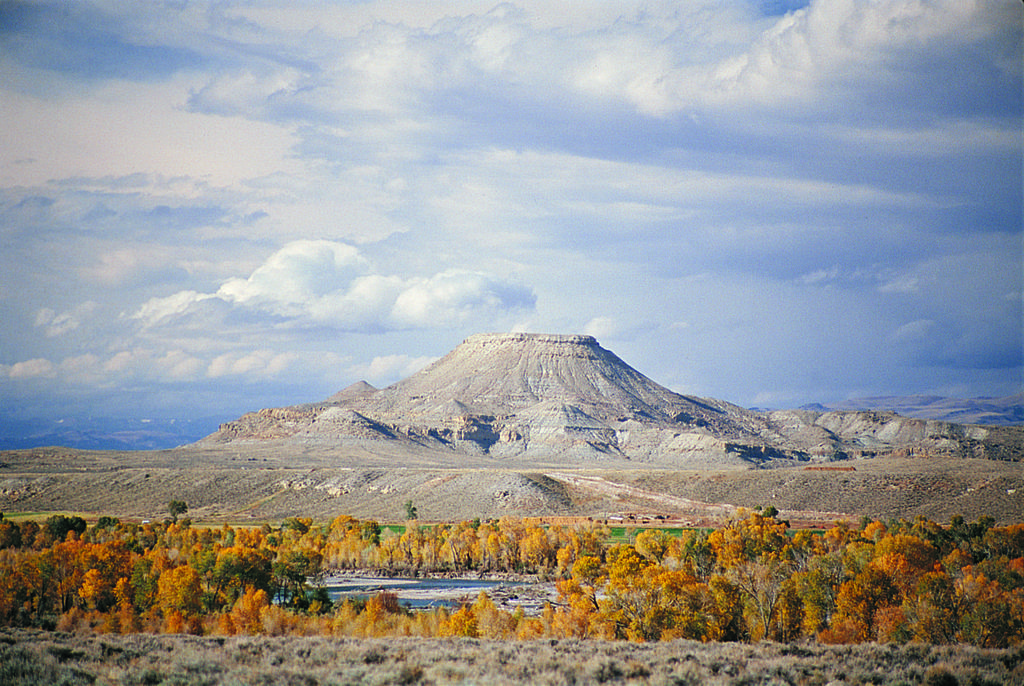Describe this image in one or two sentences. There are trees, water and mountains at the back. There are clouds in the sky. 